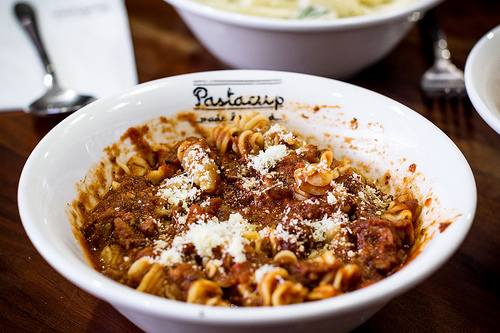<image>
Is the food on the bowl? Yes. Looking at the image, I can see the food is positioned on top of the bowl, with the bowl providing support. 